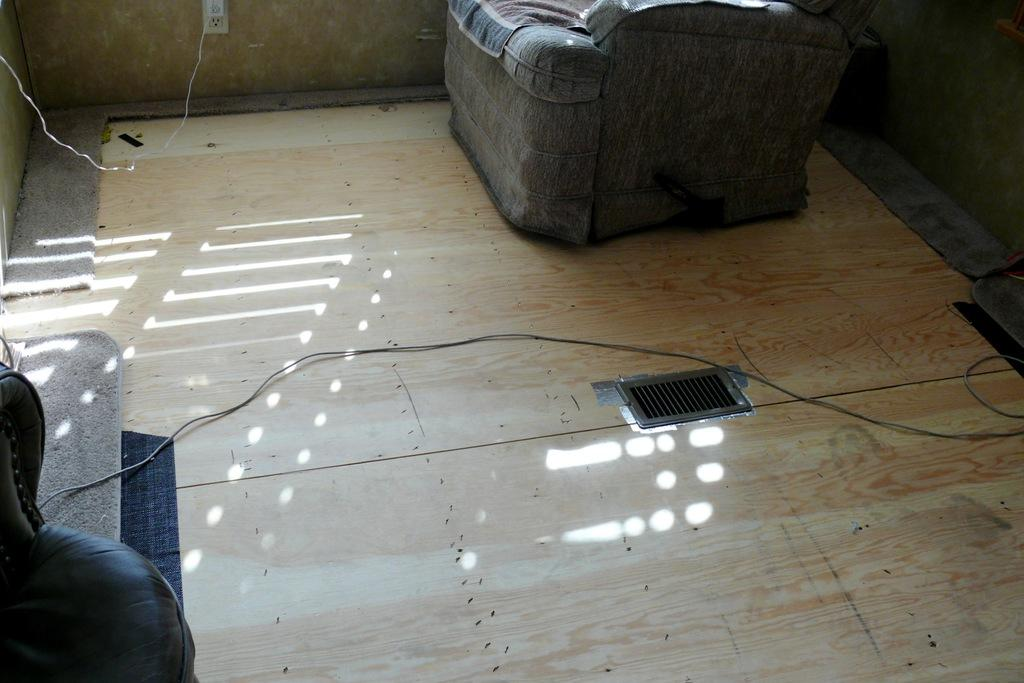What type of furniture is present in the image? There is a couch in the image. What else can be seen in the image besides the couch? There is a wire, a floor mat on the left side, a socket with a cable, and the cable attached to the wall. What type of cork is visible in the image? There is no cork present in the image. Can you describe the alley in the image? There is no alley present in the image. 